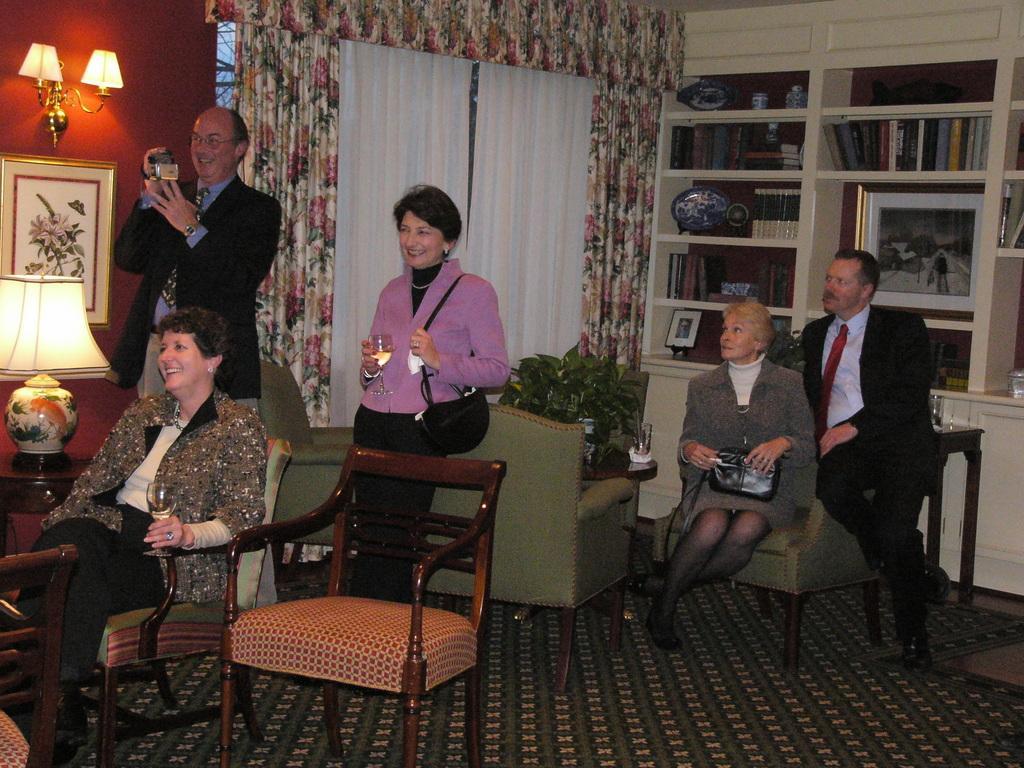How would you summarize this image in a sentence or two? In this picture there is a woman sitting on a chair and holding a glass in her hand. There is a man standing and holding a camera in his hand. There is also another woman holding a glass and handbag in her hand. There is a flower pot on the sofa. There is a a man and a woman holding bag is sitting on the sofa. There are some books, frame, box and other objects in the shelf. There is a colorful curtain , lamp and a carpet. 